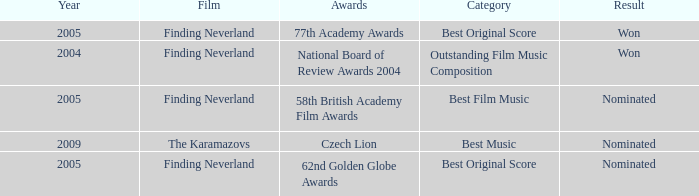How many years were there for the 62nd golden globe awards? 2005.0. 